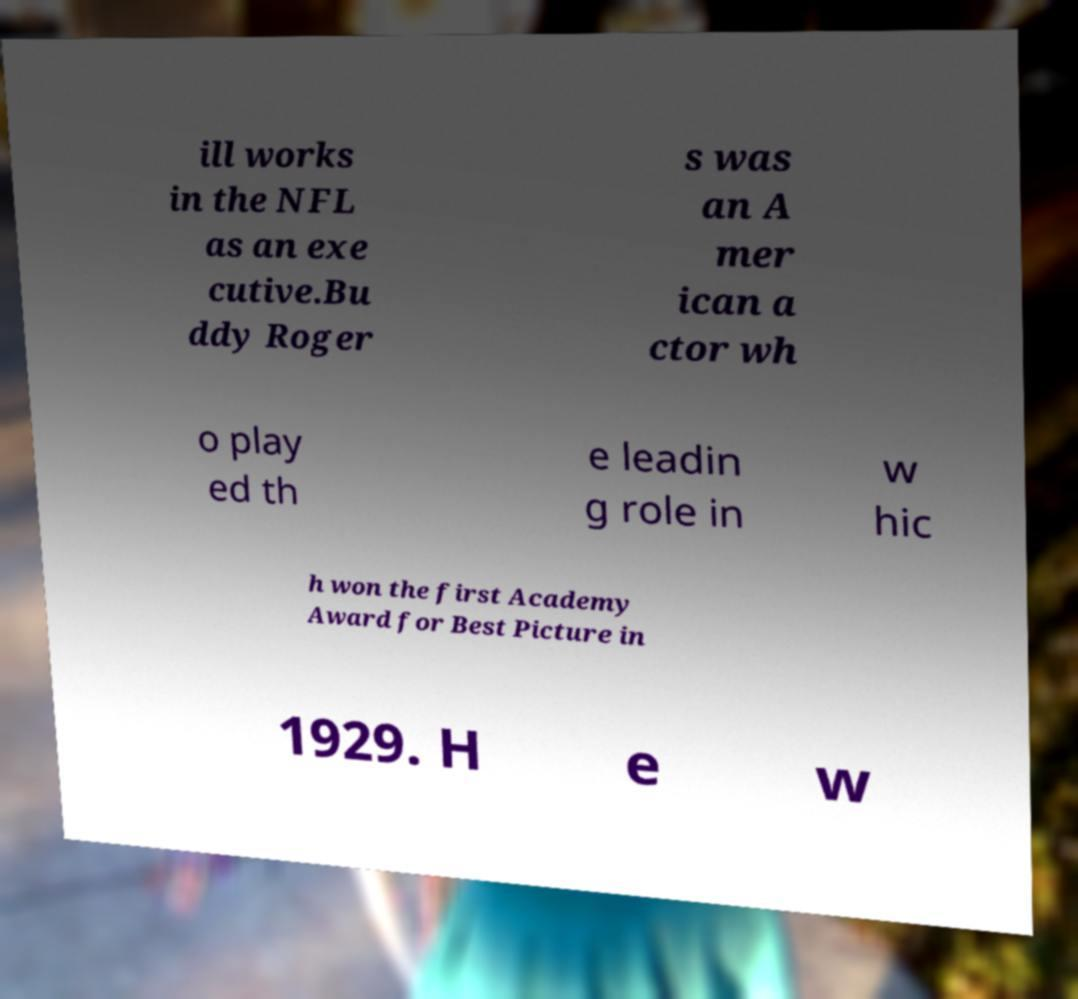For documentation purposes, I need the text within this image transcribed. Could you provide that? ill works in the NFL as an exe cutive.Bu ddy Roger s was an A mer ican a ctor wh o play ed th e leadin g role in w hic h won the first Academy Award for Best Picture in 1929. H e w 